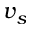<formula> <loc_0><loc_0><loc_500><loc_500>v _ { s }</formula> 